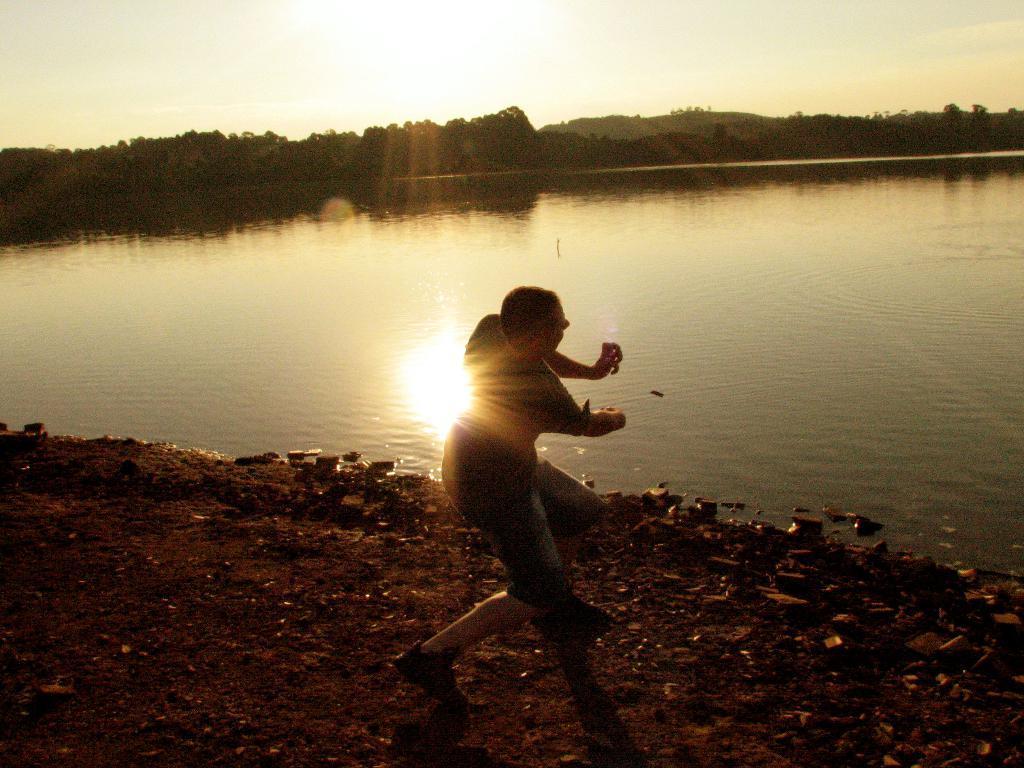Please provide a concise description of this image. In this image I can see the lake in the middle and I can see a person in front of the lake in the foreground ,at the top I can see sun light and the sky and trees. 